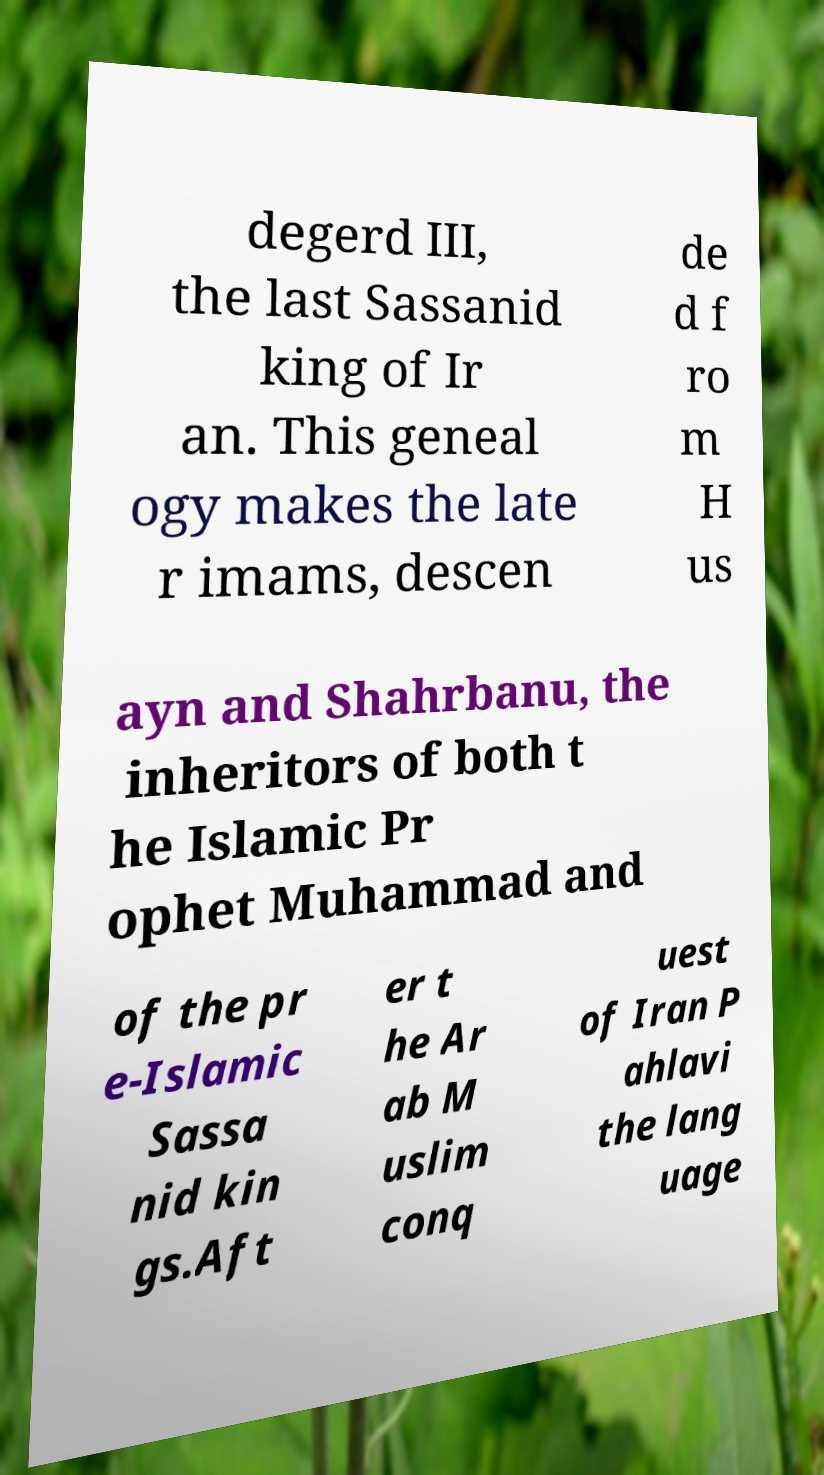Can you read and provide the text displayed in the image?This photo seems to have some interesting text. Can you extract and type it out for me? degerd III, the last Sassanid king of Ir an. This geneal ogy makes the late r imams, descen de d f ro m H us ayn and Shahrbanu, the inheritors of both t he Islamic Pr ophet Muhammad and of the pr e-Islamic Sassa nid kin gs.Aft er t he Ar ab M uslim conq uest of Iran P ahlavi the lang uage 